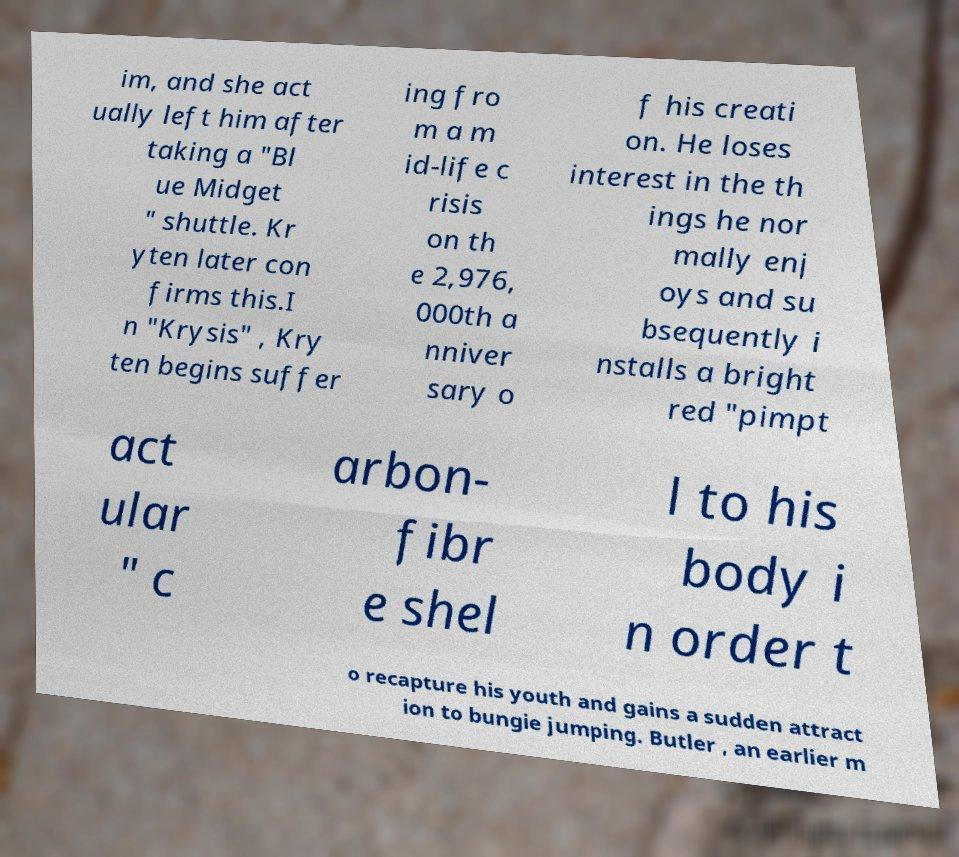Can you read and provide the text displayed in the image?This photo seems to have some interesting text. Can you extract and type it out for me? im, and she act ually left him after taking a "Bl ue Midget " shuttle. Kr yten later con firms this.I n "Krysis" , Kry ten begins suffer ing fro m a m id-life c risis on th e 2,976, 000th a nniver sary o f his creati on. He loses interest in the th ings he nor mally enj oys and su bsequently i nstalls a bright red "pimpt act ular " c arbon- fibr e shel l to his body i n order t o recapture his youth and gains a sudden attract ion to bungie jumping. Butler , an earlier m 